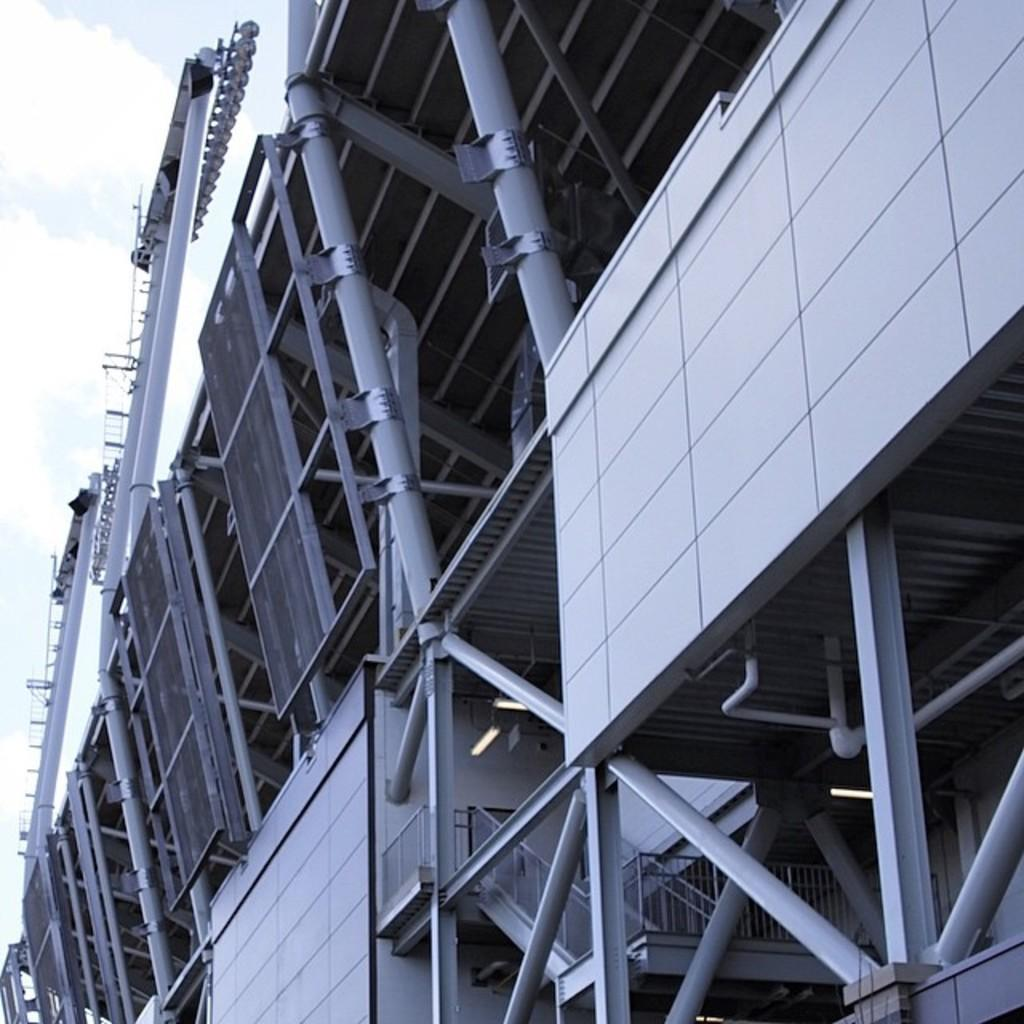What type of material is used for the frames on the building? The frames on the building are made of metal. What can be seen on the top of the building? There is a pipe on the top of the building. What is attached to the pipe? There are spotlights on the pipe. What type of design is featured on the rat in the image? There is no rat present in the image; it only features a building with metal frames, a pipe, and spotlights. What kind of meal is being prepared in the image? There is no meal preparation visible in the image; it only shows a building with metal frames, a pipe, and spotlights. 